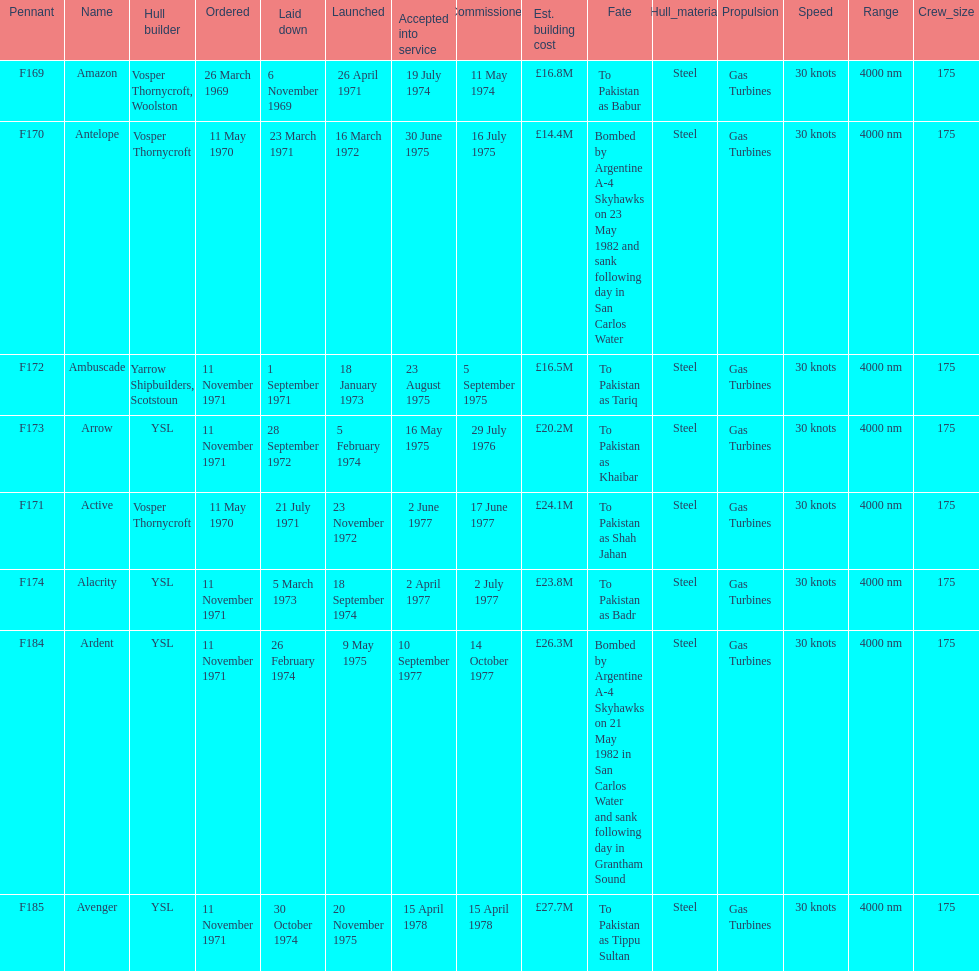The arrow was ordered on november 11, 1971. what was the previous ship? Ambuscade. 